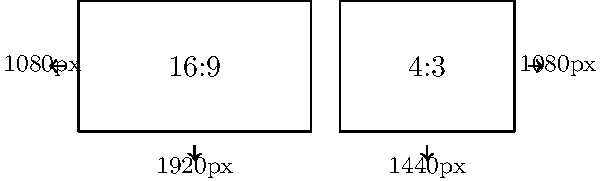As a video analyst, you're comparing two popular video resolutions: 1920x1080 (16:9) and 1440x1080 (4:3). Calculate the aspect ratio of each resolution as a simplified fraction and determine the percentage difference in width between the two resolutions, assuming they have the same height. Let's approach this step-by-step:

1. Calculate the aspect ratios:

   a) For 1920x1080 (16:9):
      Aspect ratio = 1920 : 1080
      Simplify by dividing both numbers by their GCD (120):
      1920 ÷ 120 : 1080 ÷ 120 = 16 : 9

   b) For 1440x1080 (4:3):
      Aspect ratio = 1440 : 1080
      Simplify by dividing both numbers by their GCD (360):
      1440 ÷ 360 : 1080 ÷ 360 = 4 : 3

2. Calculate the percentage difference in width:

   a) Width of 16:9 resolution: 1920 pixels
   b) Width of 4:3 resolution: 1440 pixels
   c) Difference in width: 1920 - 1440 = 480 pixels

   Percentage difference = (Difference / Original) × 100
                         = (480 / 1440) × 100
                         = 0.3333... × 100
                         ≈ 33.33%

Therefore, the 16:9 resolution is approximately 33.33% wider than the 4:3 resolution when they have the same height.
Answer: 16:9 and 4:3; 33.33% 